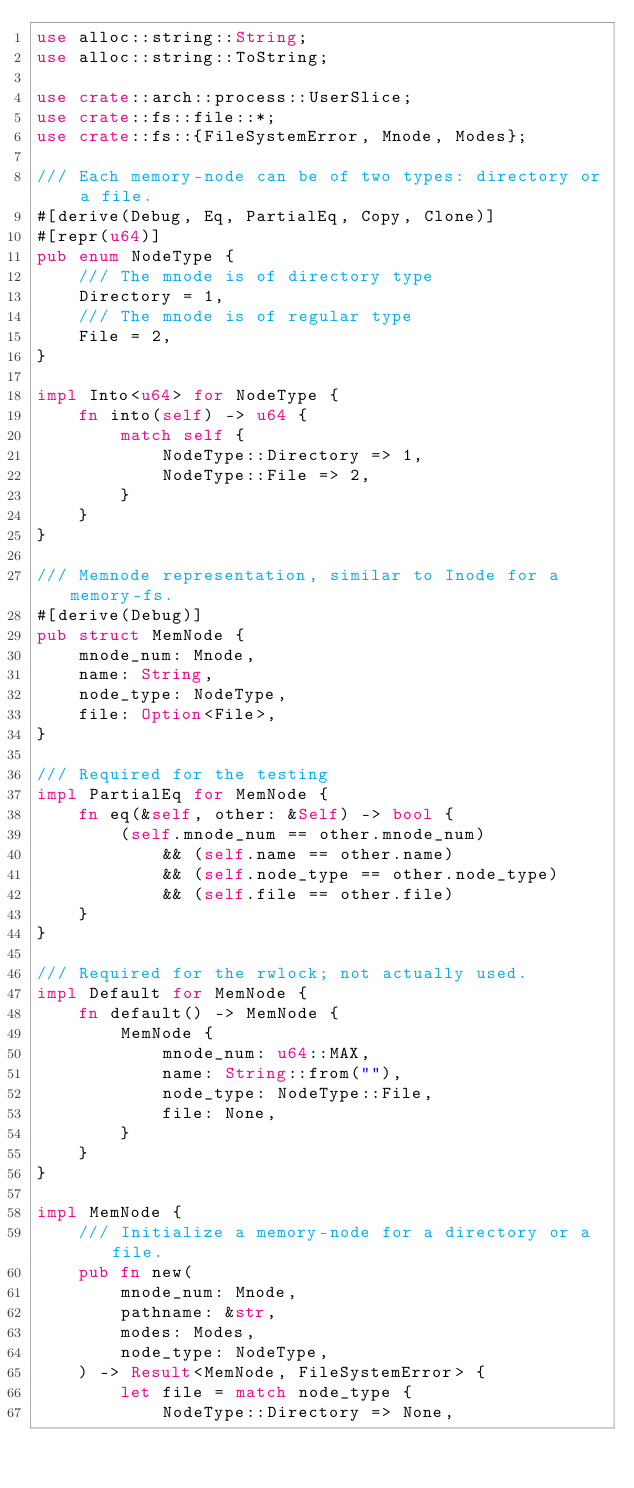Convert code to text. <code><loc_0><loc_0><loc_500><loc_500><_Rust_>use alloc::string::String;
use alloc::string::ToString;

use crate::arch::process::UserSlice;
use crate::fs::file::*;
use crate::fs::{FileSystemError, Mnode, Modes};

/// Each memory-node can be of two types: directory or a file.
#[derive(Debug, Eq, PartialEq, Copy, Clone)]
#[repr(u64)]
pub enum NodeType {
    /// The mnode is of directory type
    Directory = 1,
    /// The mnode is of regular type
    File = 2,
}

impl Into<u64> for NodeType {
    fn into(self) -> u64 {
        match self {
            NodeType::Directory => 1,
            NodeType::File => 2,
        }
    }
}

/// Memnode representation, similar to Inode for a memory-fs.
#[derive(Debug)]
pub struct MemNode {
    mnode_num: Mnode,
    name: String,
    node_type: NodeType,
    file: Option<File>,
}

/// Required for the testing
impl PartialEq for MemNode {
    fn eq(&self, other: &Self) -> bool {
        (self.mnode_num == other.mnode_num)
            && (self.name == other.name)
            && (self.node_type == other.node_type)
            && (self.file == other.file)
    }
}

/// Required for the rwlock; not actually used.
impl Default for MemNode {
    fn default() -> MemNode {
        MemNode {
            mnode_num: u64::MAX,
            name: String::from(""),
            node_type: NodeType::File,
            file: None,
        }
    }
}

impl MemNode {
    /// Initialize a memory-node for a directory or a file.
    pub fn new(
        mnode_num: Mnode,
        pathname: &str,
        modes: Modes,
        node_type: NodeType,
    ) -> Result<MemNode, FileSystemError> {
        let file = match node_type {
            NodeType::Directory => None,</code> 